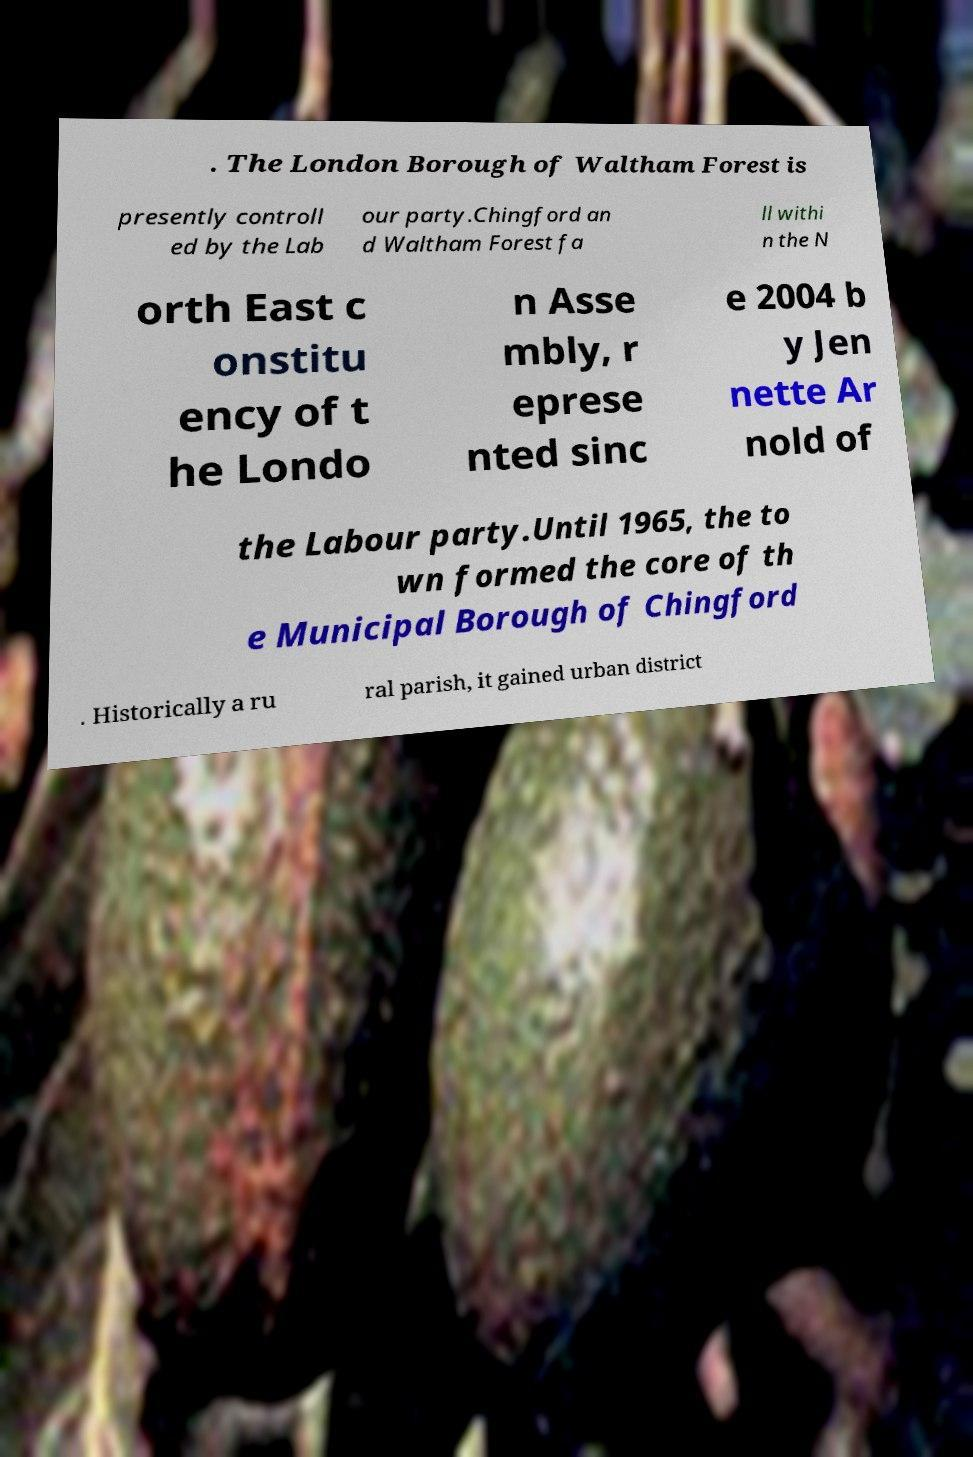Can you accurately transcribe the text from the provided image for me? . The London Borough of Waltham Forest is presently controll ed by the Lab our party.Chingford an d Waltham Forest fa ll withi n the N orth East c onstitu ency of t he Londo n Asse mbly, r eprese nted sinc e 2004 b y Jen nette Ar nold of the Labour party.Until 1965, the to wn formed the core of th e Municipal Borough of Chingford . Historically a ru ral parish, it gained urban district 